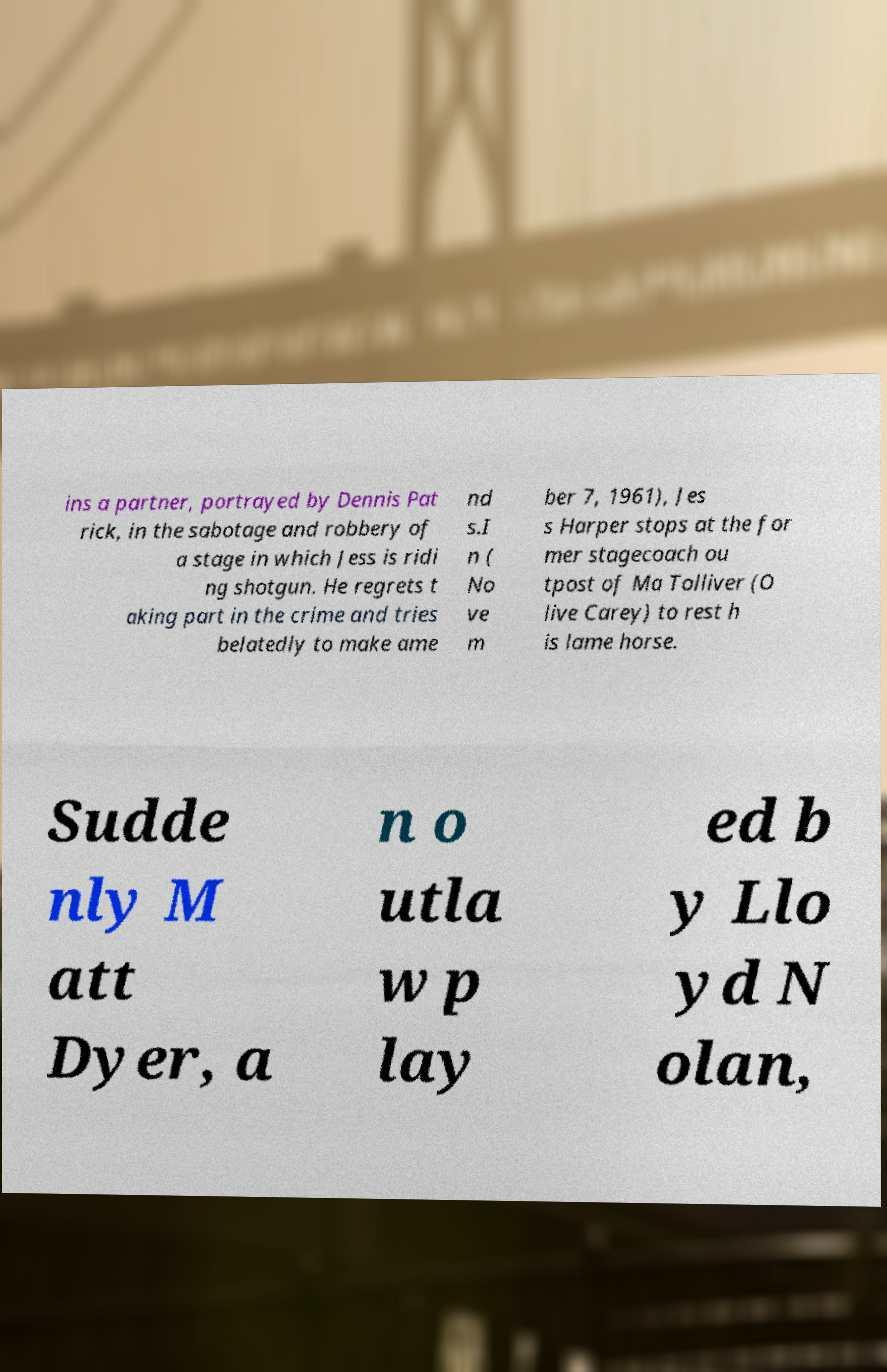Please identify and transcribe the text found in this image. ins a partner, portrayed by Dennis Pat rick, in the sabotage and robbery of a stage in which Jess is ridi ng shotgun. He regrets t aking part in the crime and tries belatedly to make ame nd s.I n ( No ve m ber 7, 1961), Jes s Harper stops at the for mer stagecoach ou tpost of Ma Tolliver (O live Carey) to rest h is lame horse. Sudde nly M att Dyer, a n o utla w p lay ed b y Llo yd N olan, 